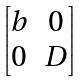<formula> <loc_0><loc_0><loc_500><loc_500>\begin{bmatrix} b & 0 \\ 0 & D \end{bmatrix}</formula> 